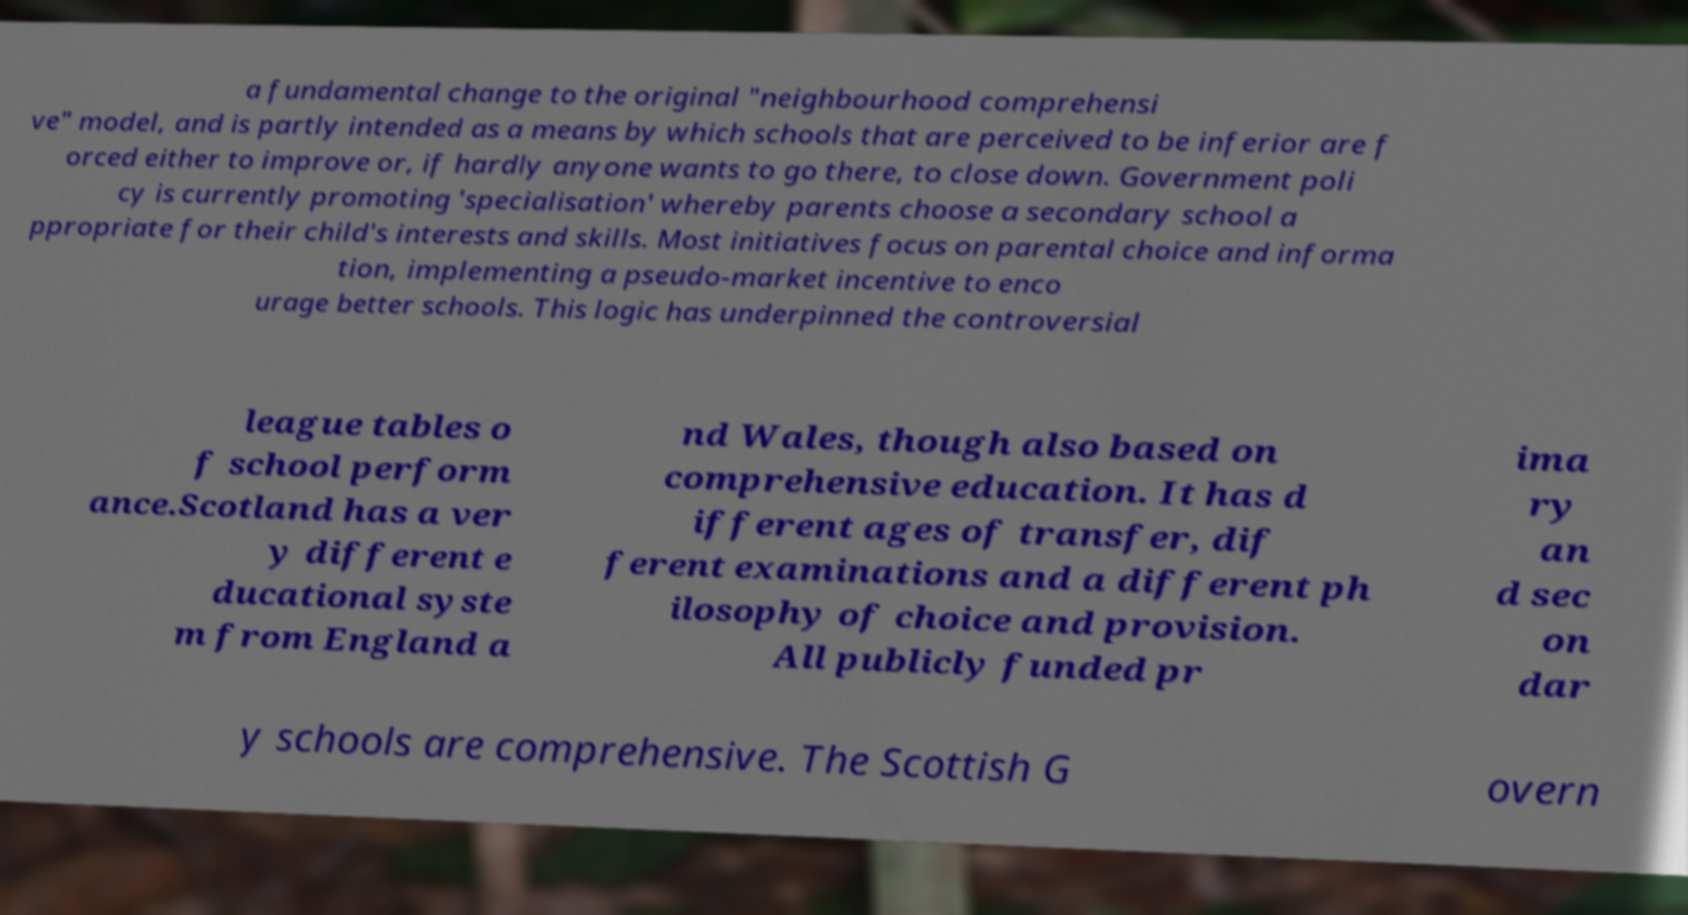I need the written content from this picture converted into text. Can you do that? a fundamental change to the original "neighbourhood comprehensi ve" model, and is partly intended as a means by which schools that are perceived to be inferior are f orced either to improve or, if hardly anyone wants to go there, to close down. Government poli cy is currently promoting 'specialisation' whereby parents choose a secondary school a ppropriate for their child's interests and skills. Most initiatives focus on parental choice and informa tion, implementing a pseudo-market incentive to enco urage better schools. This logic has underpinned the controversial league tables o f school perform ance.Scotland has a ver y different e ducational syste m from England a nd Wales, though also based on comprehensive education. It has d ifferent ages of transfer, dif ferent examinations and a different ph ilosophy of choice and provision. All publicly funded pr ima ry an d sec on dar y schools are comprehensive. The Scottish G overn 